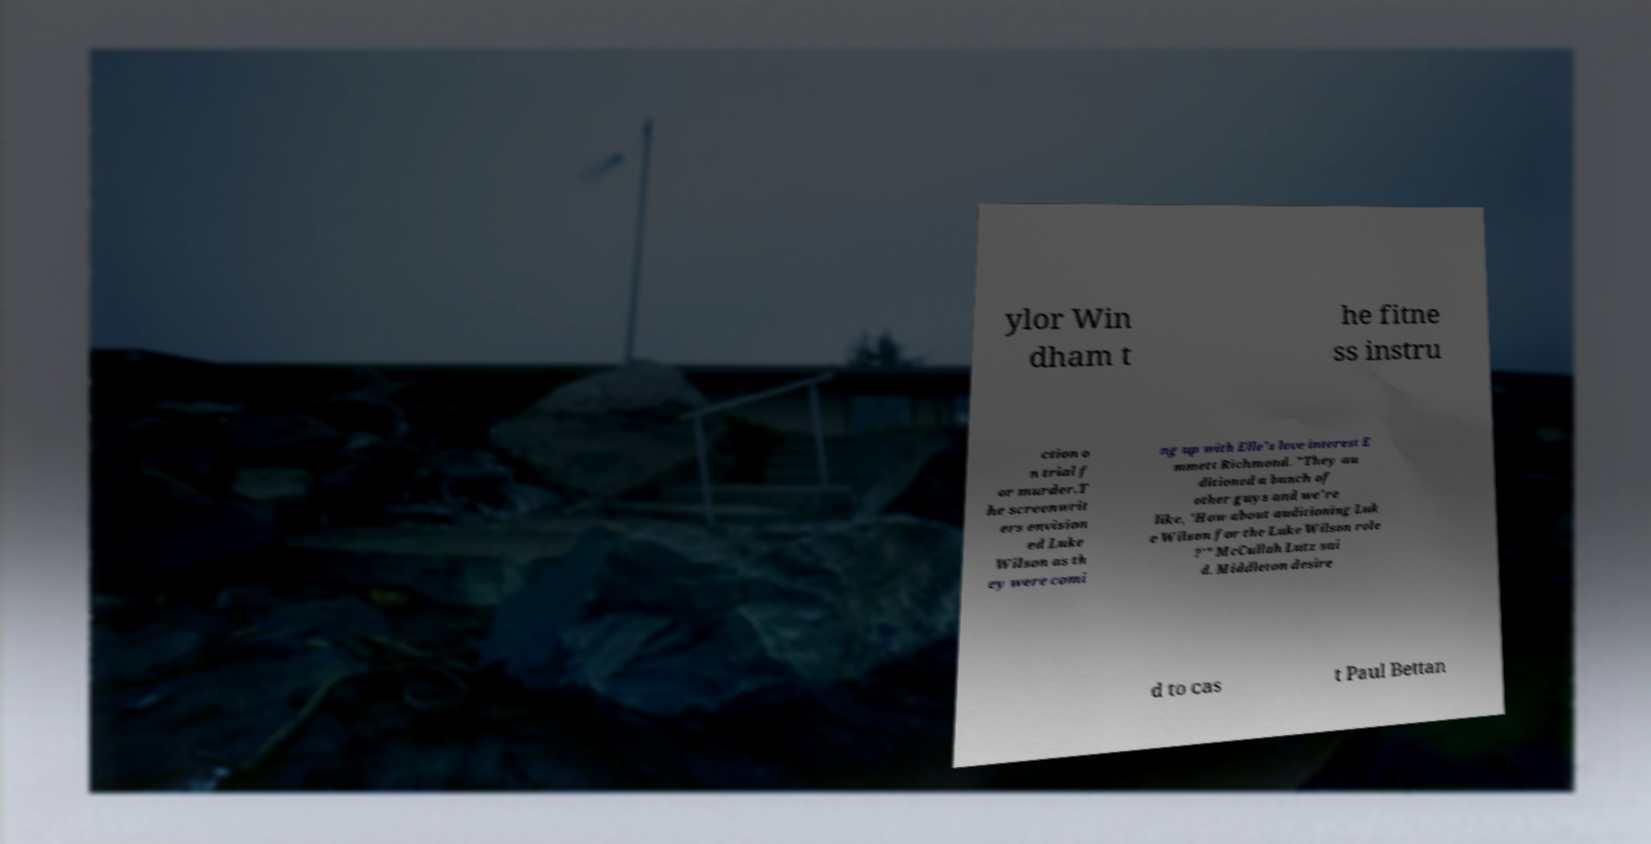Can you read and provide the text displayed in the image?This photo seems to have some interesting text. Can you extract and type it out for me? ylor Win dham t he fitne ss instru ction o n trial f or murder.T he screenwrit ers envision ed Luke Wilson as th ey were comi ng up with Elle's love interest E mmett Richmond. "They au ditioned a bunch of other guys and we're like, 'How about auditioning Luk e Wilson for the Luke Wilson role ?'" McCullah Lutz sai d. Middleton desire d to cas t Paul Bettan 